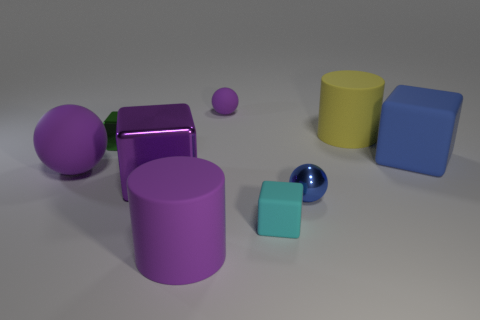Does this arrangement of objects remind you of anything specific, like a game or a particular setting? The arrangement of these geometric shapes somewhat resembles the setup of a simplified and abstract educational toy or a children's block set. The variety in shapes and colors suggests a playful environment intended for learning or creative exploration, such as sorting by shape or color. 